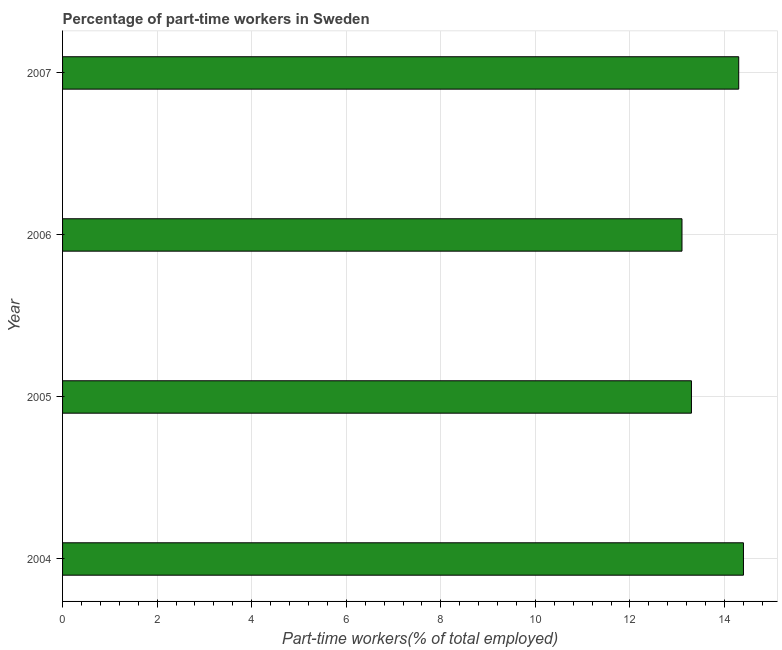What is the title of the graph?
Your answer should be very brief. Percentage of part-time workers in Sweden. What is the label or title of the X-axis?
Provide a succinct answer. Part-time workers(% of total employed). What is the label or title of the Y-axis?
Keep it short and to the point. Year. What is the percentage of part-time workers in 2006?
Provide a succinct answer. 13.1. Across all years, what is the maximum percentage of part-time workers?
Your answer should be compact. 14.4. Across all years, what is the minimum percentage of part-time workers?
Offer a very short reply. 13.1. In which year was the percentage of part-time workers minimum?
Provide a succinct answer. 2006. What is the sum of the percentage of part-time workers?
Your answer should be very brief. 55.1. What is the difference between the percentage of part-time workers in 2005 and 2006?
Make the answer very short. 0.2. What is the average percentage of part-time workers per year?
Provide a short and direct response. 13.78. What is the median percentage of part-time workers?
Give a very brief answer. 13.8. Do a majority of the years between 2004 and 2005 (inclusive) have percentage of part-time workers greater than 10.4 %?
Your response must be concise. Yes. What is the ratio of the percentage of part-time workers in 2004 to that in 2005?
Provide a succinct answer. 1.08. Is the percentage of part-time workers in 2006 less than that in 2007?
Provide a succinct answer. Yes. In how many years, is the percentage of part-time workers greater than the average percentage of part-time workers taken over all years?
Make the answer very short. 2. How many bars are there?
Give a very brief answer. 4. Are the values on the major ticks of X-axis written in scientific E-notation?
Provide a short and direct response. No. What is the Part-time workers(% of total employed) in 2004?
Offer a terse response. 14.4. What is the Part-time workers(% of total employed) of 2005?
Keep it short and to the point. 13.3. What is the Part-time workers(% of total employed) in 2006?
Provide a short and direct response. 13.1. What is the Part-time workers(% of total employed) in 2007?
Your answer should be compact. 14.3. What is the difference between the Part-time workers(% of total employed) in 2004 and 2005?
Ensure brevity in your answer.  1.1. What is the difference between the Part-time workers(% of total employed) in 2005 and 2007?
Your answer should be compact. -1. What is the difference between the Part-time workers(% of total employed) in 2006 and 2007?
Provide a succinct answer. -1.2. What is the ratio of the Part-time workers(% of total employed) in 2004 to that in 2005?
Ensure brevity in your answer.  1.08. What is the ratio of the Part-time workers(% of total employed) in 2004 to that in 2006?
Offer a terse response. 1.1. What is the ratio of the Part-time workers(% of total employed) in 2004 to that in 2007?
Give a very brief answer. 1.01. What is the ratio of the Part-time workers(% of total employed) in 2005 to that in 2007?
Your answer should be compact. 0.93. What is the ratio of the Part-time workers(% of total employed) in 2006 to that in 2007?
Ensure brevity in your answer.  0.92. 